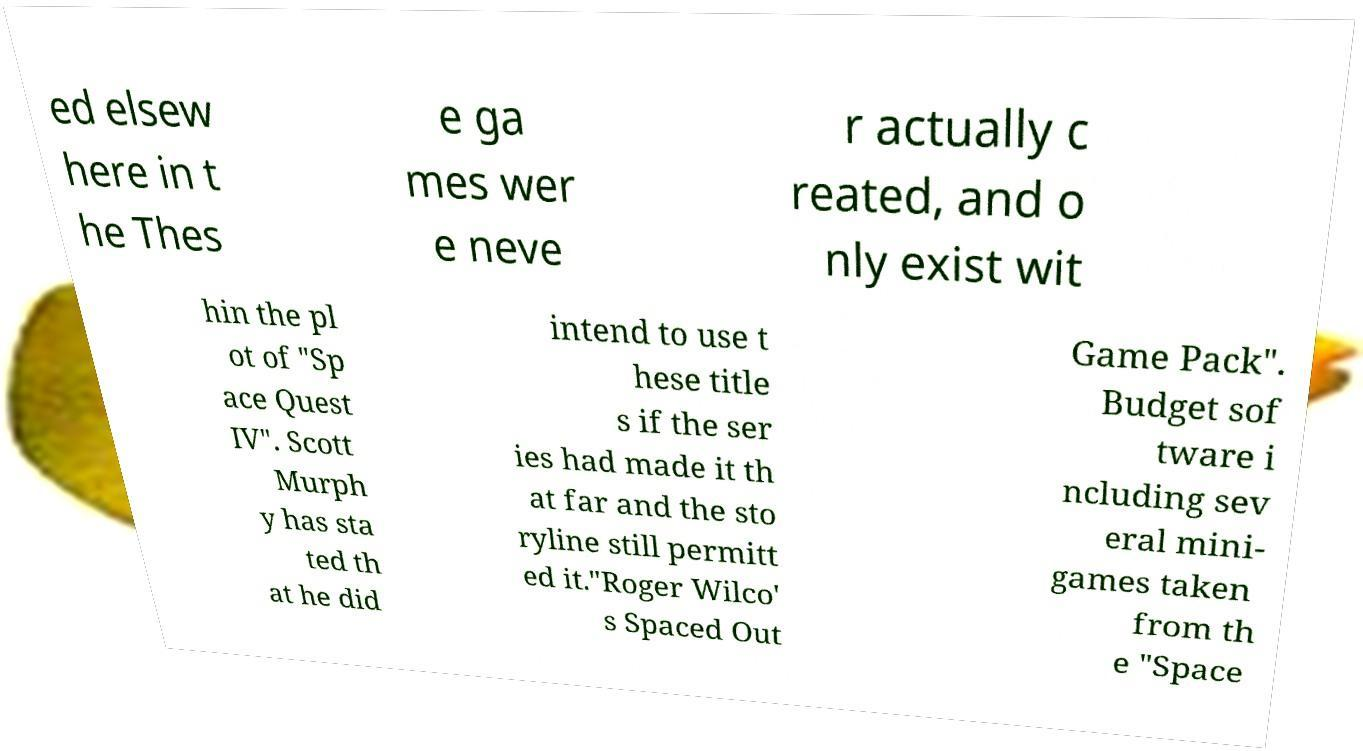Can you read and provide the text displayed in the image?This photo seems to have some interesting text. Can you extract and type it out for me? ed elsew here in t he Thes e ga mes wer e neve r actually c reated, and o nly exist wit hin the pl ot of "Sp ace Quest IV". Scott Murph y has sta ted th at he did intend to use t hese title s if the ser ies had made it th at far and the sto ryline still permitt ed it."Roger Wilco' s Spaced Out Game Pack". Budget sof tware i ncluding sev eral mini- games taken from th e "Space 